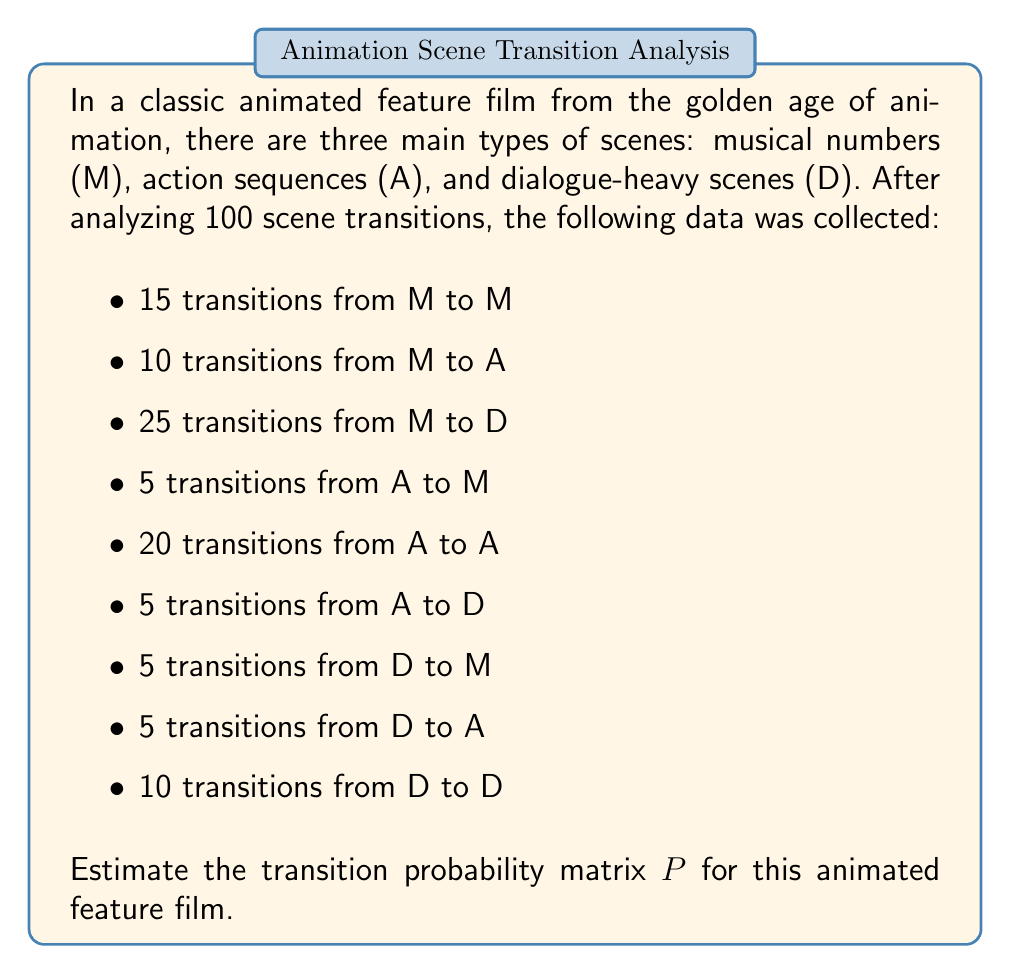Solve this math problem. To estimate the transition probability matrix, we need to calculate the probabilities of transitioning from each scene type to every other scene type, including itself. We'll follow these steps:

1. Count the total number of transitions from each scene type:
   M: 15 + 10 + 25 = 50
   A: 5 + 20 + 5 = 30
   D: 5 + 5 + 10 = 20

2. Calculate the probabilities for each transition:

   From M:
   P(M to M) = 15 / 50 = 0.3
   P(M to A) = 10 / 50 = 0.2
   P(M to D) = 25 / 50 = 0.5

   From A:
   P(A to M) = 5 / 30 ≈ 0.167
   P(A to A) = 20 / 30 ≈ 0.667
   P(A to D) = 5 / 30 ≈ 0.167

   From D:
   P(D to M) = 5 / 20 = 0.25
   P(D to A) = 5 / 20 = 0.25
   P(D to D) = 10 / 20 = 0.5

3. Construct the transition probability matrix:

   $$P = \begin{bmatrix}
   0.3 & 0.2 & 0.5 \\
   0.167 & 0.667 & 0.167 \\
   0.25 & 0.25 & 0.5
   \end{bmatrix}$$

   Where the rows represent the current scene type (M, A, D) and the columns represent the next scene type (M, A, D).
Answer: $$P = \begin{bmatrix}
0.3 & 0.2 & 0.5 \\
0.167 & 0.667 & 0.167 \\
0.25 & 0.25 & 0.5
\end{bmatrix}$$ 